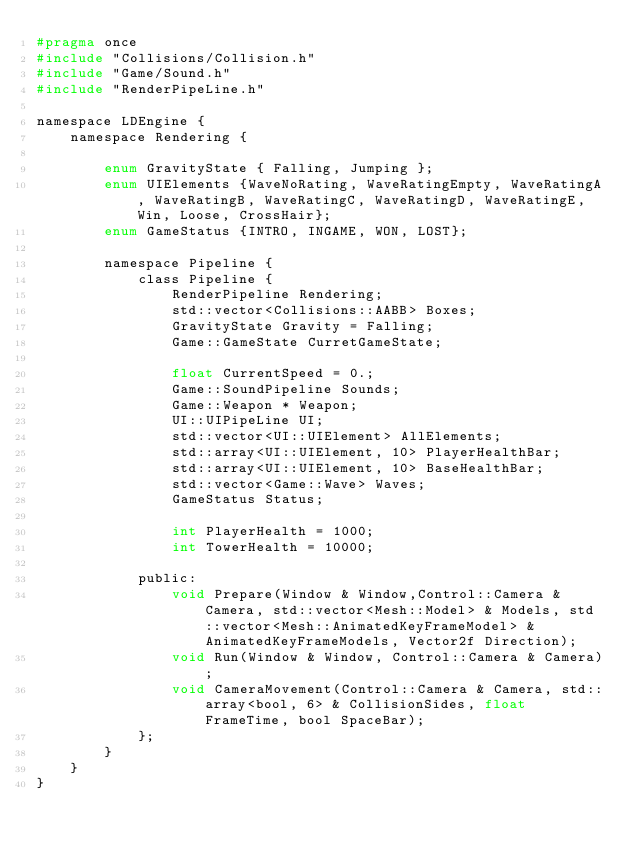<code> <loc_0><loc_0><loc_500><loc_500><_C_>#pragma once
#include "Collisions/Collision.h"
#include "Game/Sound.h"
#include "RenderPipeLine.h"

namespace LDEngine {
	namespace Rendering {

		enum GravityState { Falling, Jumping }; 
		enum UIElements {WaveNoRating, WaveRatingEmpty, WaveRatingA, WaveRatingB, WaveRatingC, WaveRatingD, WaveRatingE, Win, Loose, CrossHair};
		enum GameStatus {INTRO, INGAME, WON, LOST};

		namespace Pipeline {
			class Pipeline {
				RenderPipeline Rendering; 
				std::vector<Collisions::AABB> Boxes; 
				GravityState Gravity = Falling;
				Game::GameState CurretGameState; 

				float CurrentSpeed = 0.; 
				Game::SoundPipeline Sounds; 
				Game::Weapon * Weapon; 
				UI::UIPipeLine UI; 
				std::vector<UI::UIElement> AllElements; 
				std::array<UI::UIElement, 10> PlayerHealthBar; 
				std::array<UI::UIElement, 10> BaseHealthBar;
				std::vector<Game::Wave> Waves; 
				GameStatus Status; 

				int PlayerHealth = 1000;
				int TowerHealth = 10000;

			public: 
				void Prepare(Window & Window,Control::Camera & Camera, std::vector<Mesh::Model> & Models, std::vector<Mesh::AnimatedKeyFrameModel> & AnimatedKeyFrameModels, Vector2f Direction);
				void Run(Window & Window, Control::Camera & Camera); 
				void CameraMovement(Control::Camera & Camera, std::array<bool, 6> & CollisionSides, float FrameTime, bool SpaceBar);
			};
		}
	}
}</code> 